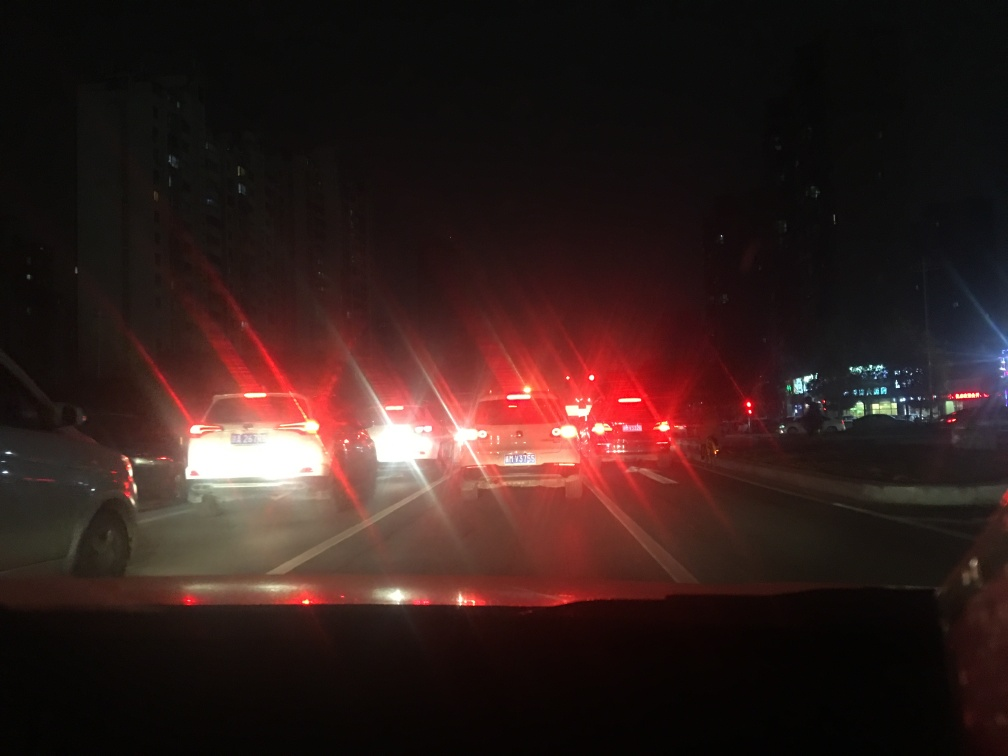What is the quality of this image?
A. Excellent
B. Very poor
C. Good The quality of the image is rather low, considering factors such as lighting and clarity. The picture appears to be taken at night with a strong glare from the vehicle lights, possibly due to the camera's limitations in a low-light setting. This results in an image that lacks detail and crispness, making it hard to discern specific elements. The overexposure from the lights causes a visual disturbance, which further detracts from the overall quality of the photograph. 